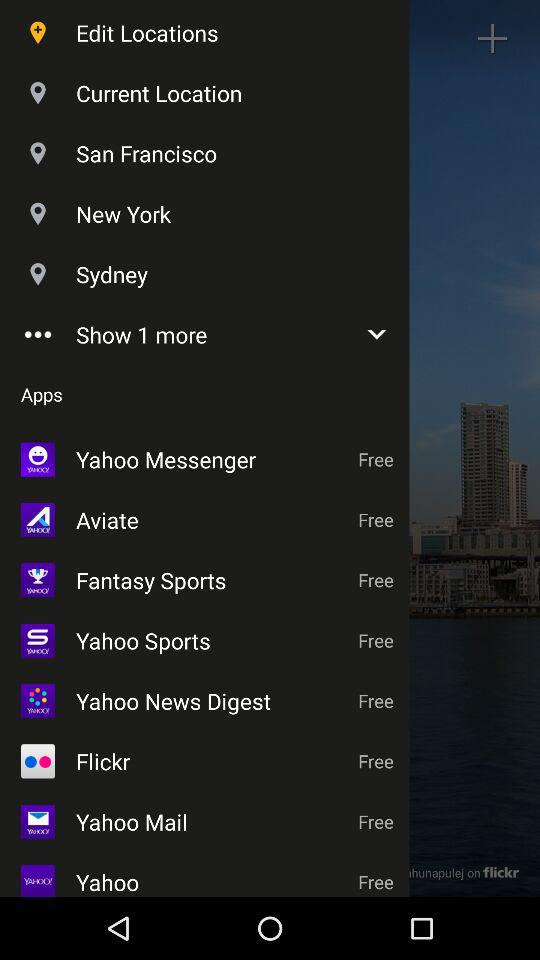How many more options are there to show? There is 1 more option to show. 